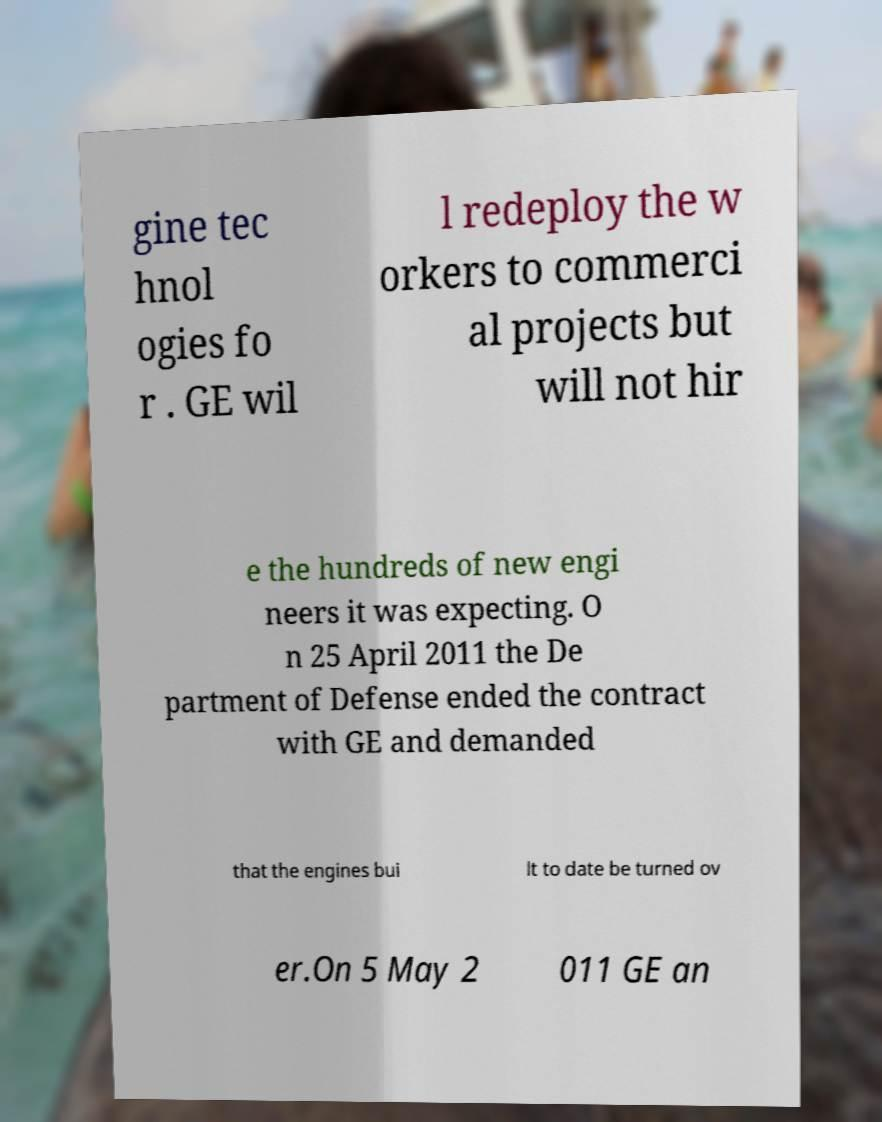Could you extract and type out the text from this image? gine tec hnol ogies fo r . GE wil l redeploy the w orkers to commerci al projects but will not hir e the hundreds of new engi neers it was expecting. O n 25 April 2011 the De partment of Defense ended the contract with GE and demanded that the engines bui lt to date be turned ov er.On 5 May 2 011 GE an 